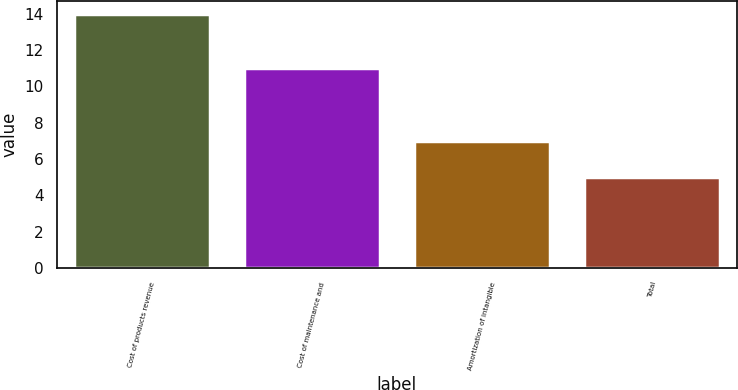Convert chart to OTSL. <chart><loc_0><loc_0><loc_500><loc_500><bar_chart><fcel>Cost of products revenue<fcel>Cost of maintenance and<fcel>Amortization of intangible<fcel>Total<nl><fcel>14<fcel>11<fcel>7<fcel>5<nl></chart> 